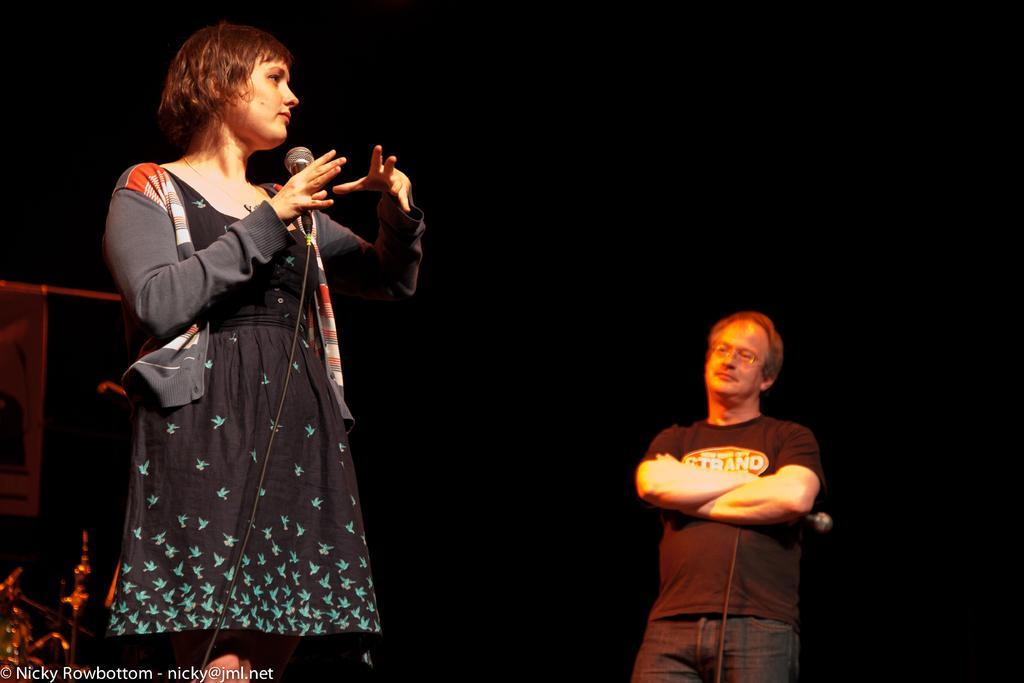Please provide a concise description of this image. In this picture we can a woman wearing a black dress, standing in the front and holding the microphone in the hand. Behind we can see a man wearing black t-shirt, standing and looking to her. Behind we can see the dark background. 